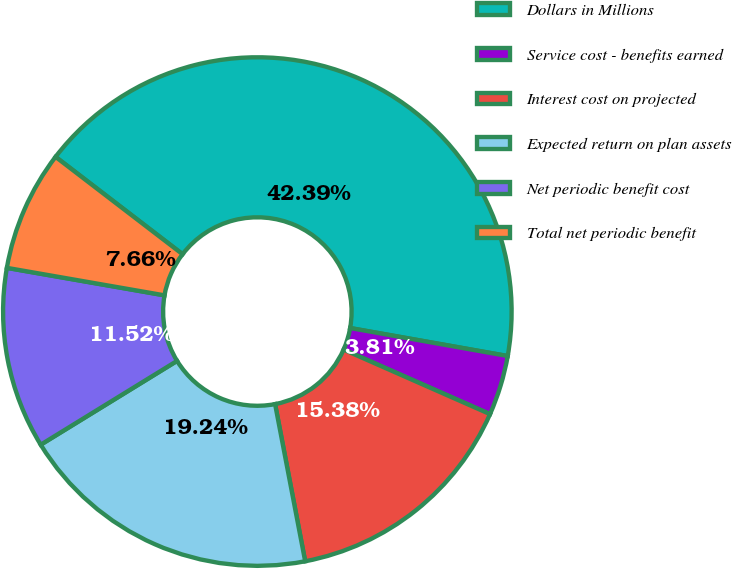<chart> <loc_0><loc_0><loc_500><loc_500><pie_chart><fcel>Dollars in Millions<fcel>Service cost - benefits earned<fcel>Interest cost on projected<fcel>Expected return on plan assets<fcel>Net periodic benefit cost<fcel>Total net periodic benefit<nl><fcel>42.39%<fcel>3.81%<fcel>15.38%<fcel>19.24%<fcel>11.52%<fcel>7.66%<nl></chart> 